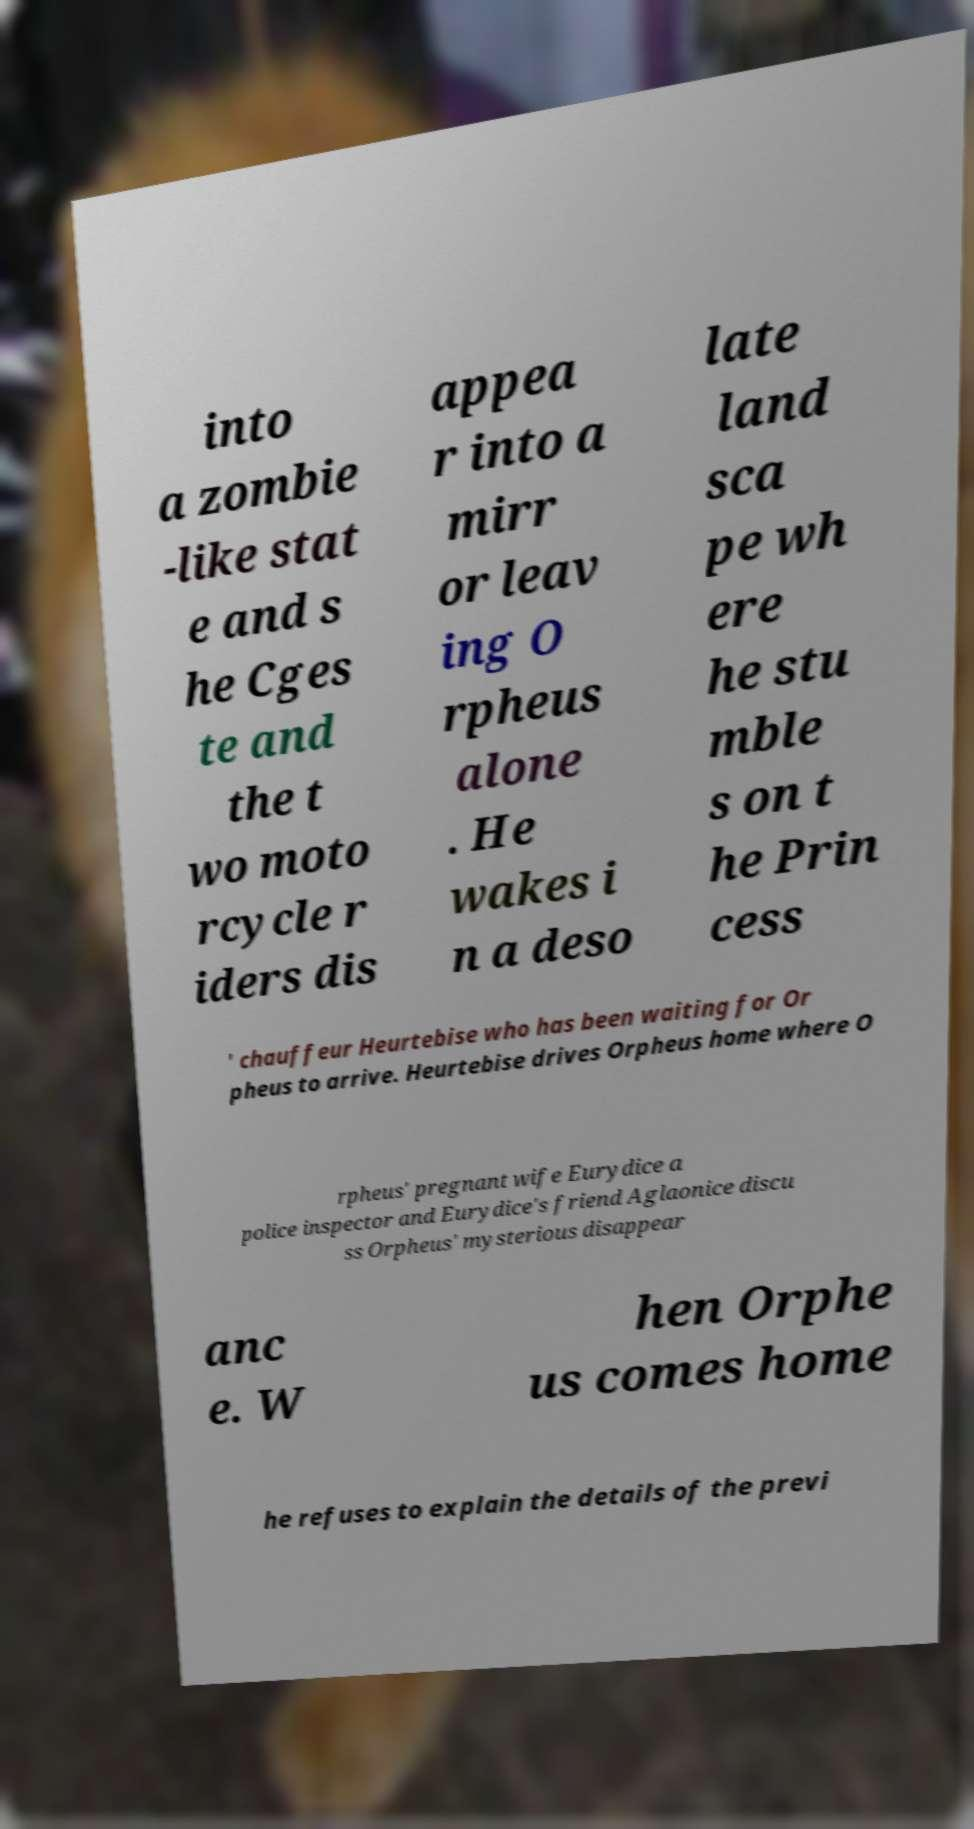Can you accurately transcribe the text from the provided image for me? into a zombie -like stat e and s he Cges te and the t wo moto rcycle r iders dis appea r into a mirr or leav ing O rpheus alone . He wakes i n a deso late land sca pe wh ere he stu mble s on t he Prin cess ' chauffeur Heurtebise who has been waiting for Or pheus to arrive. Heurtebise drives Orpheus home where O rpheus' pregnant wife Eurydice a police inspector and Eurydice's friend Aglaonice discu ss Orpheus' mysterious disappear anc e. W hen Orphe us comes home he refuses to explain the details of the previ 